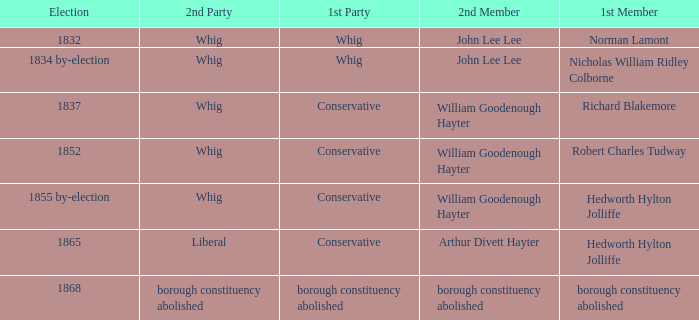What's the 2nd party of 2nd member william goodenough hayter when the 1st member is hedworth hylton jolliffe? Whig. 